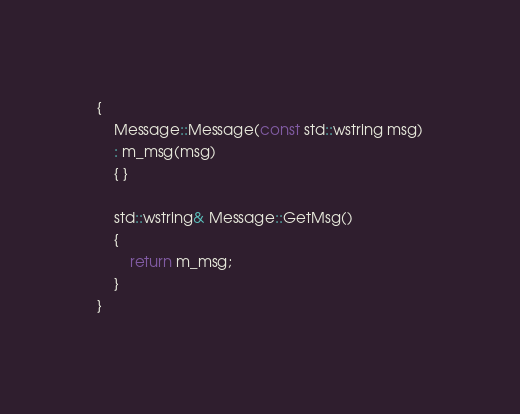Convert code to text. <code><loc_0><loc_0><loc_500><loc_500><_C++_>{
	Message::Message(const std::wstring msg)
	: m_msg(msg)
	{ }

	std::wstring& Message::GetMsg()
	{
		return m_msg;
	}
}</code> 